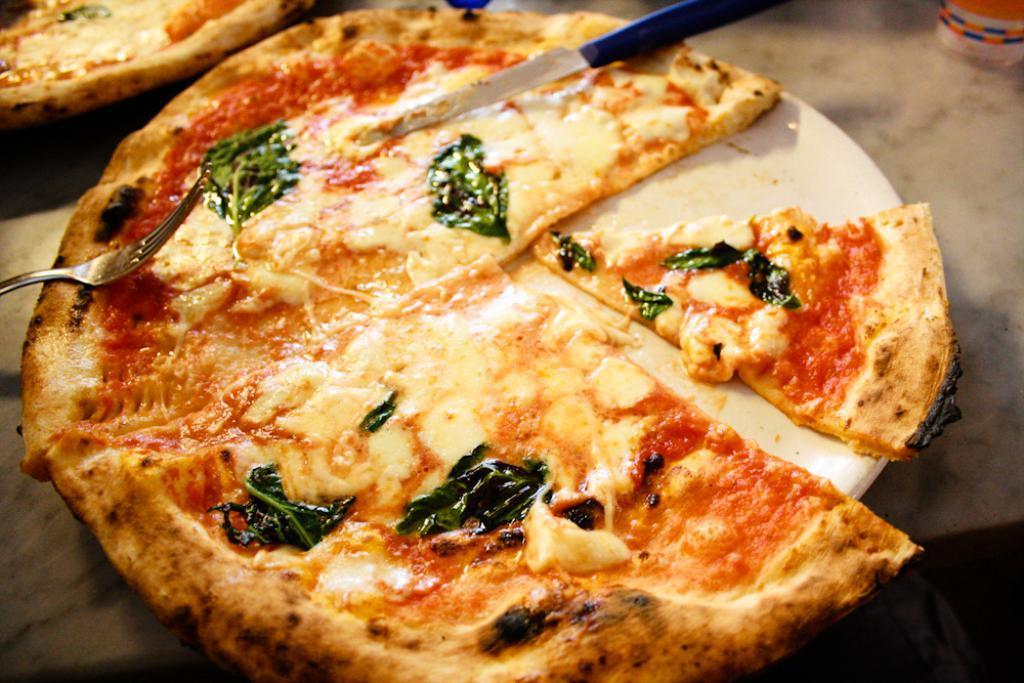In one or two sentences, can you explain what this image depicts? We can see pizzas,knife,fork and plate on surface. 